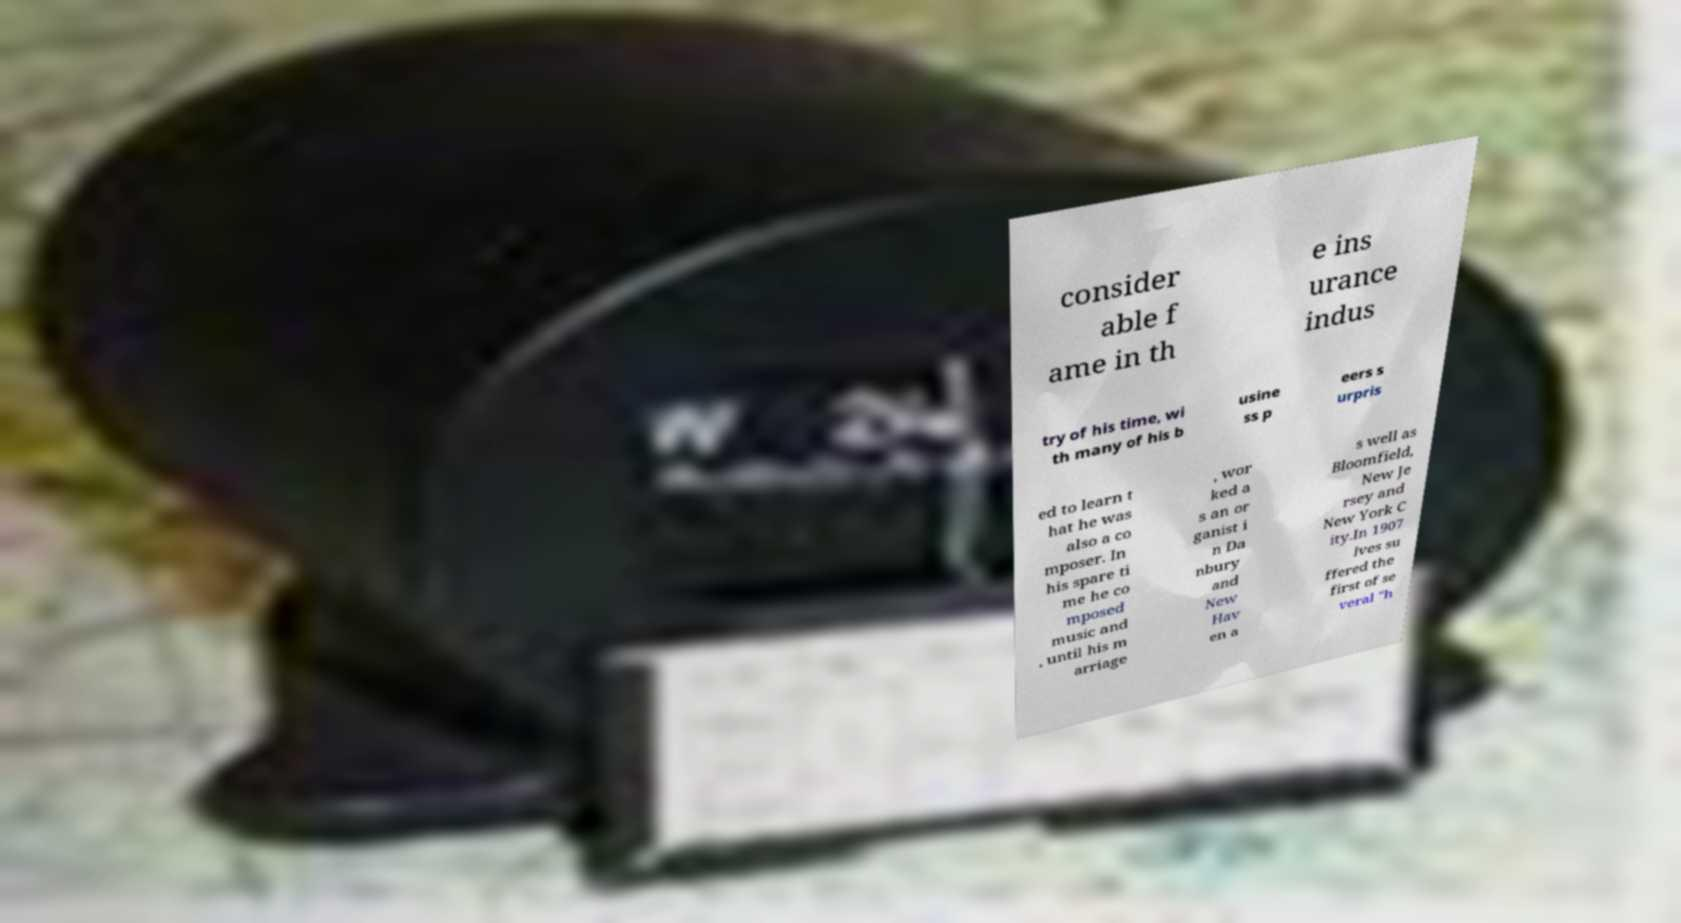Can you read and provide the text displayed in the image?This photo seems to have some interesting text. Can you extract and type it out for me? consider able f ame in th e ins urance indus try of his time, wi th many of his b usine ss p eers s urpris ed to learn t hat he was also a co mposer. In his spare ti me he co mposed music and , until his m arriage , wor ked a s an or ganist i n Da nbury and New Hav en a s well as Bloomfield, New Je rsey and New York C ity.In 1907 Ives su ffered the first of se veral "h 